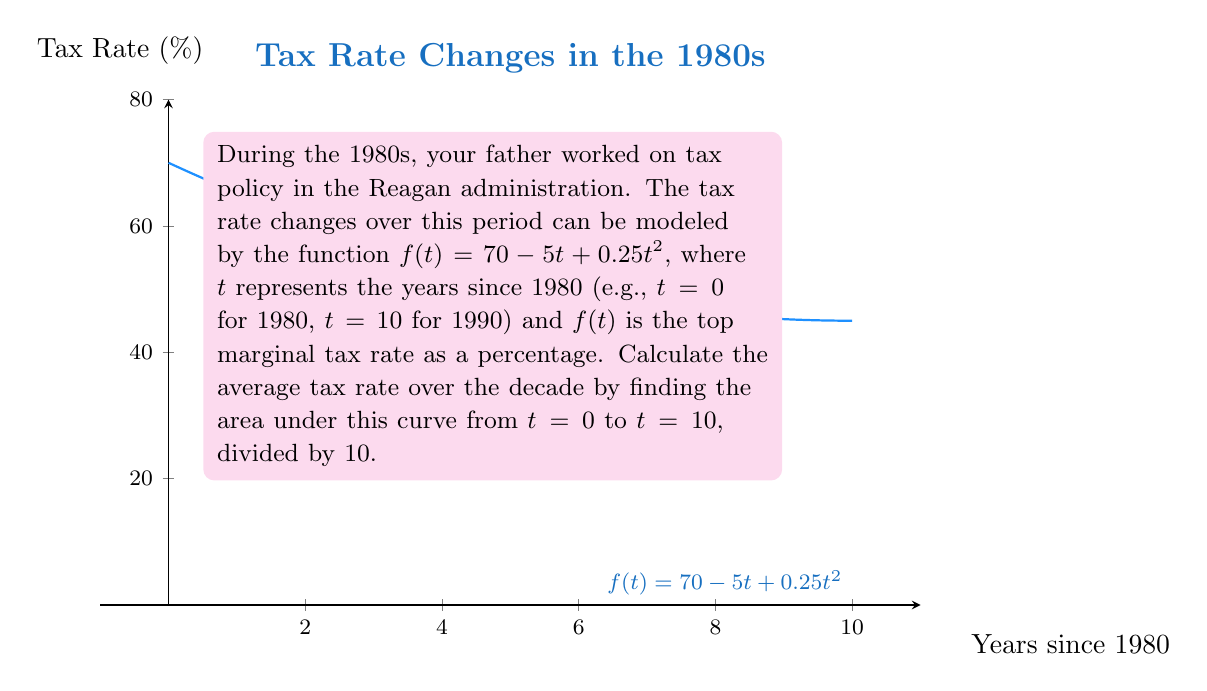Help me with this question. To solve this problem, we need to:
1) Find the definite integral of $f(t)$ from $t=0$ to $t=10$
2) Divide the result by 10 to get the average

Step 1: Integrate $f(t) = 70 - 5t + 0.25t^2$ from 0 to 10

$$\int_0^{10} (70 - 5t + 0.25t^2) dt$$

Integrating each term:
$$\left[70t - \frac{5t^2}{2} + \frac{0.25t^3}{3}\right]_0^{10}$$

Step 2: Evaluate the integral at the bounds

At $t=10$:
$$70(10) - \frac{5(10^2)}{2} + \frac{0.25(10^3)}{3} = 700 - 250 + 83.33 = 533.33$$

At $t=0$: 
$$70(0) - \frac{5(0^2)}{2} + \frac{0.25(0^3)}{3} = 0$$

The difference: $533.33 - 0 = 533.33$

Step 3: Divide by 10 to get the average

$533.33 / 10 = 53.333$

Therefore, the average tax rate over the decade was approximately 53.333%.
Answer: 53.333% 